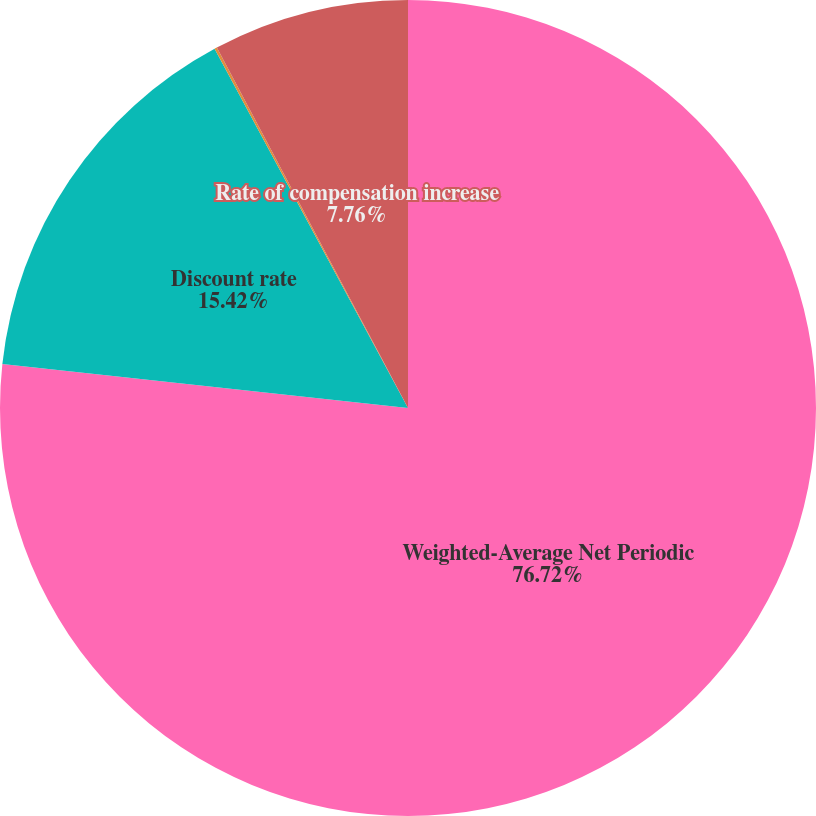Convert chart to OTSL. <chart><loc_0><loc_0><loc_500><loc_500><pie_chart><fcel>Weighted-Average Net Periodic<fcel>Discount rate<fcel>Expected return on plan assets<fcel>Rate of compensation increase<nl><fcel>76.71%<fcel>15.42%<fcel>0.1%<fcel>7.76%<nl></chart> 